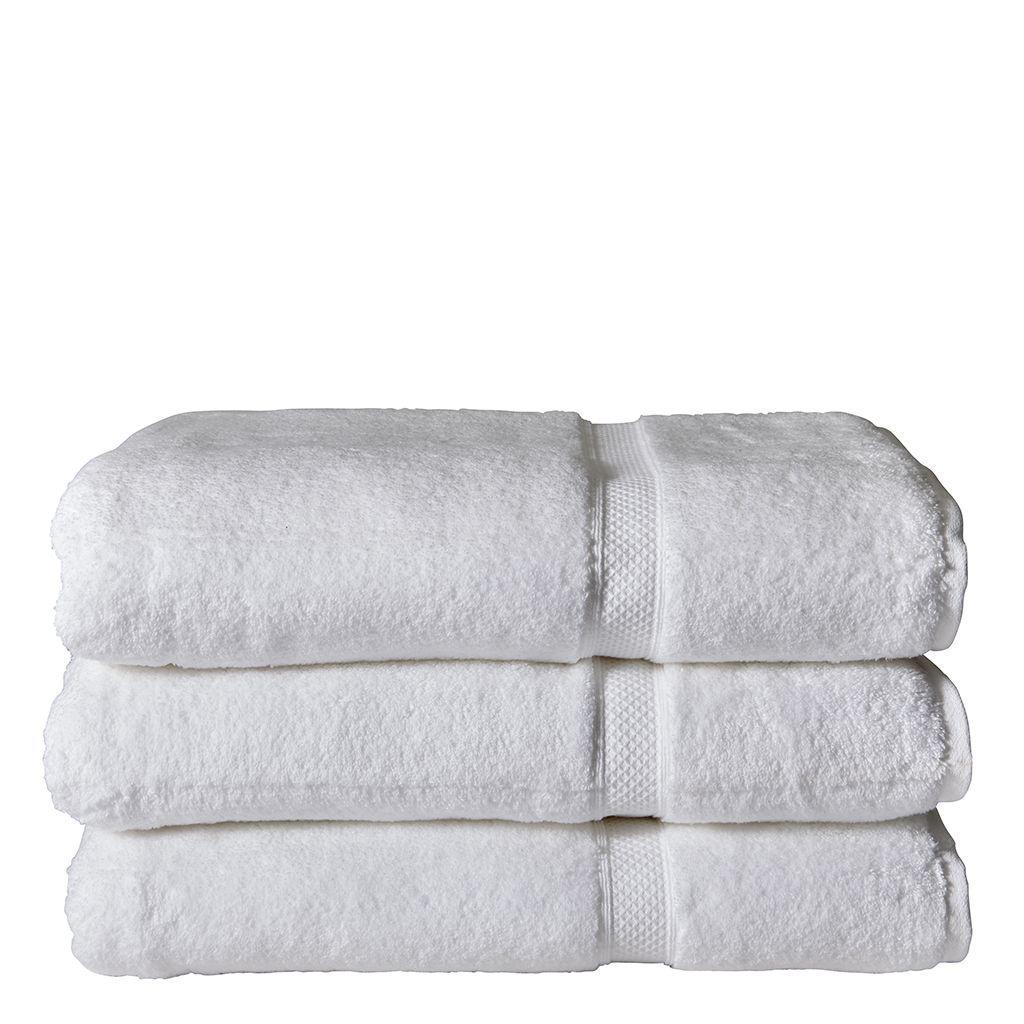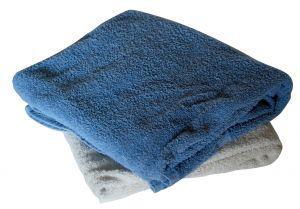The first image is the image on the left, the second image is the image on the right. Given the left and right images, does the statement "In each image there are more than two stacked towels" hold true? Answer yes or no. No. The first image is the image on the left, the second image is the image on the right. Given the left and right images, does the statement "There is a stack of three white towels in one of the images." hold true? Answer yes or no. Yes. 